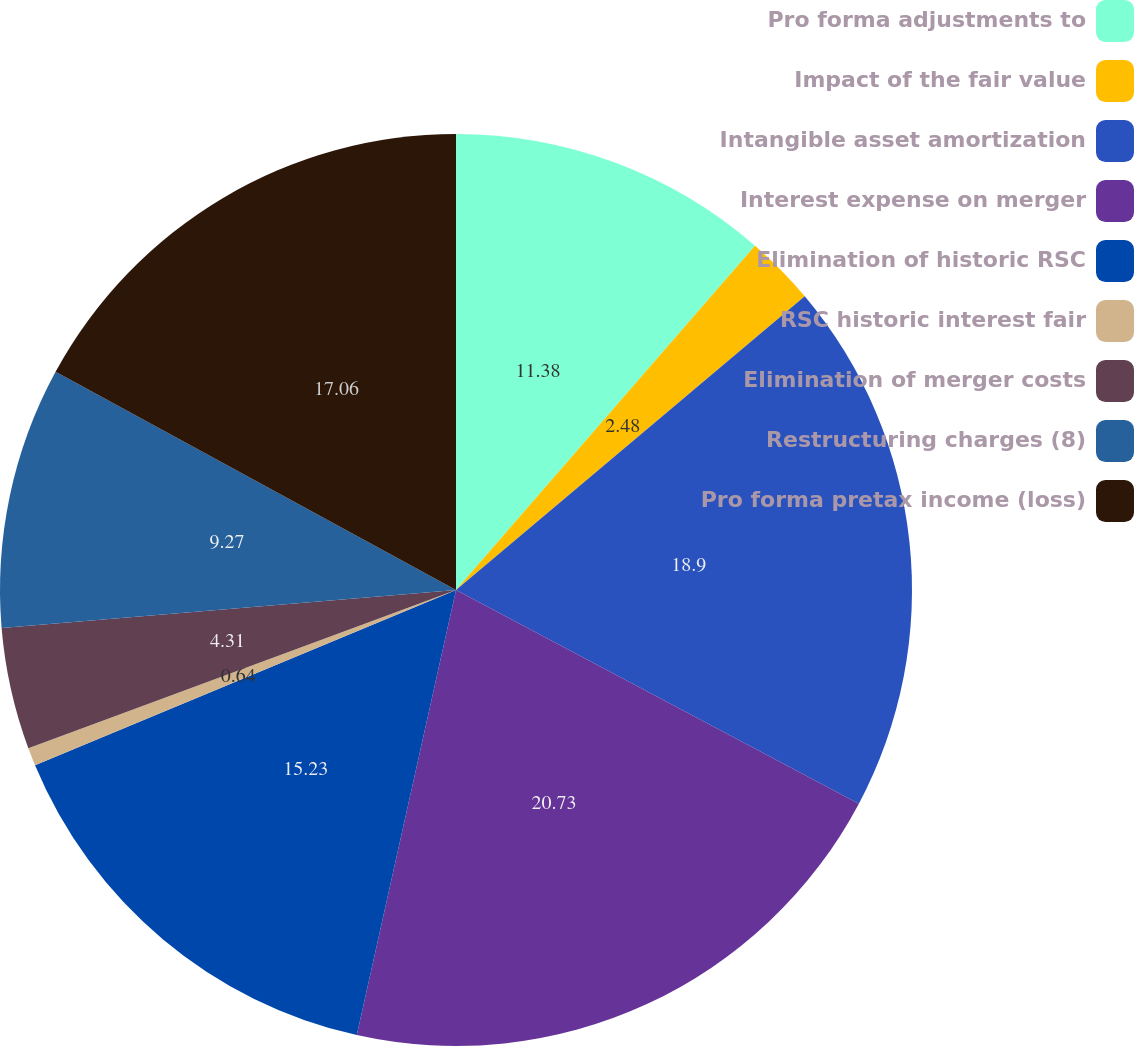Convert chart to OTSL. <chart><loc_0><loc_0><loc_500><loc_500><pie_chart><fcel>Pro forma adjustments to<fcel>Impact of the fair value<fcel>Intangible asset amortization<fcel>Interest expense on merger<fcel>Elimination of historic RSC<fcel>RSC historic interest fair<fcel>Elimination of merger costs<fcel>Restructuring charges (8)<fcel>Pro forma pretax income (loss)<nl><fcel>11.38%<fcel>2.48%<fcel>18.9%<fcel>20.73%<fcel>15.23%<fcel>0.64%<fcel>4.31%<fcel>9.27%<fcel>17.06%<nl></chart> 